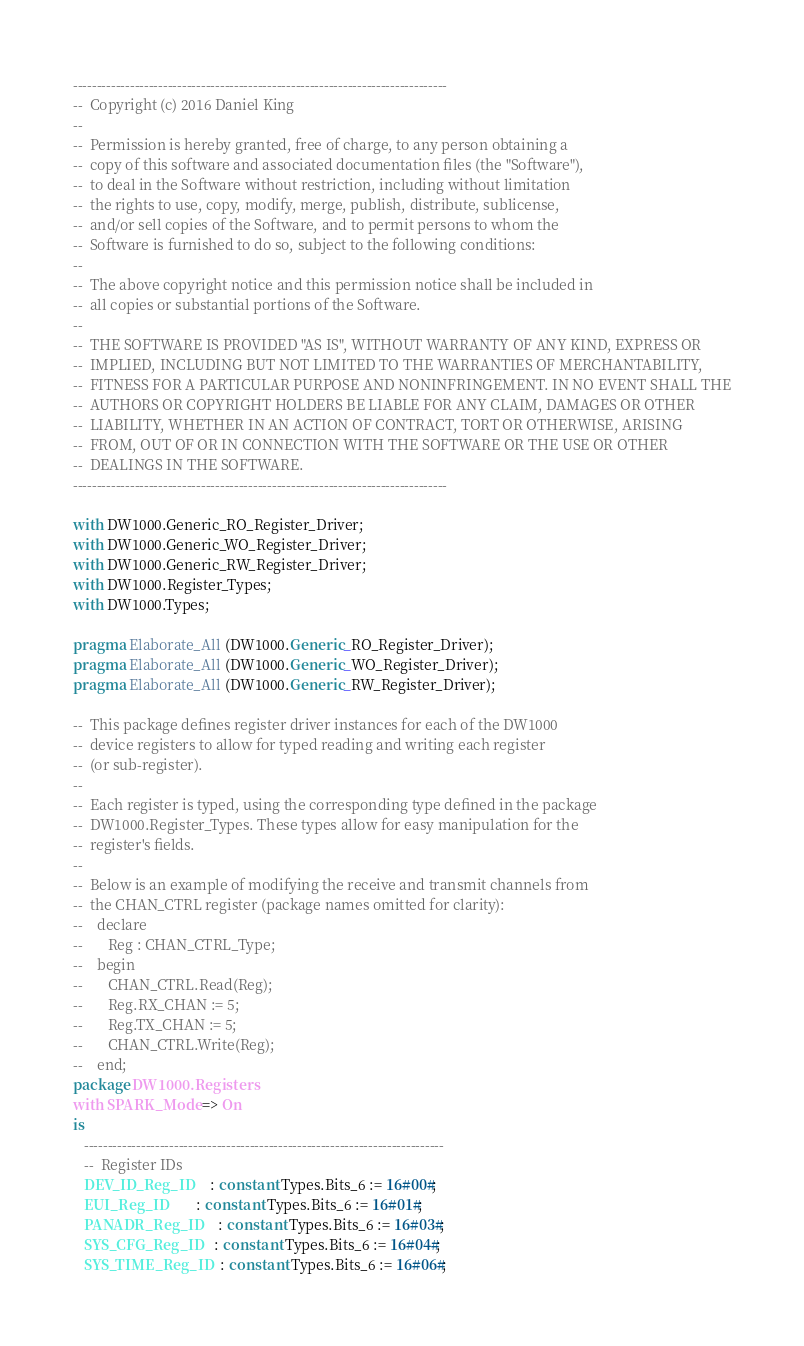Convert code to text. <code><loc_0><loc_0><loc_500><loc_500><_Ada_>-------------------------------------------------------------------------------
--  Copyright (c) 2016 Daniel King
--
--  Permission is hereby granted, free of charge, to any person obtaining a
--  copy of this software and associated documentation files (the "Software"),
--  to deal in the Software without restriction, including without limitation
--  the rights to use, copy, modify, merge, publish, distribute, sublicense,
--  and/or sell copies of the Software, and to permit persons to whom the
--  Software is furnished to do so, subject to the following conditions:
--
--  The above copyright notice and this permission notice shall be included in
--  all copies or substantial portions of the Software.
--
--  THE SOFTWARE IS PROVIDED "AS IS", WITHOUT WARRANTY OF ANY KIND, EXPRESS OR
--  IMPLIED, INCLUDING BUT NOT LIMITED TO THE WARRANTIES OF MERCHANTABILITY,
--  FITNESS FOR A PARTICULAR PURPOSE AND NONINFRINGEMENT. IN NO EVENT SHALL THE
--  AUTHORS OR COPYRIGHT HOLDERS BE LIABLE FOR ANY CLAIM, DAMAGES OR OTHER
--  LIABILITY, WHETHER IN AN ACTION OF CONTRACT, TORT OR OTHERWISE, ARISING
--  FROM, OUT OF OR IN CONNECTION WITH THE SOFTWARE OR THE USE OR OTHER
--  DEALINGS IN THE SOFTWARE.
-------------------------------------------------------------------------------

with DW1000.Generic_RO_Register_Driver;
with DW1000.Generic_WO_Register_Driver;
with DW1000.Generic_RW_Register_Driver;
with DW1000.Register_Types;
with DW1000.Types;

pragma Elaborate_All (DW1000.Generic_RO_Register_Driver);
pragma Elaborate_All (DW1000.Generic_WO_Register_Driver);
pragma Elaborate_All (DW1000.Generic_RW_Register_Driver);

--  This package defines register driver instances for each of the DW1000
--  device registers to allow for typed reading and writing each register
--  (or sub-register).
--
--  Each register is typed, using the corresponding type defined in the package
--  DW1000.Register_Types. These types allow for easy manipulation for the
--  register's fields.
--
--  Below is an example of modifying the receive and transmit channels from
--  the CHAN_CTRL register (package names omitted for clarity):
--    declare
--       Reg : CHAN_CTRL_Type;
--    begin
--       CHAN_CTRL.Read(Reg);
--       Reg.RX_CHAN := 5;
--       Reg.TX_CHAN := 5;
--       CHAN_CTRL.Write(Reg);
--    end;
package DW1000.Registers
with SPARK_Mode => On
is
   ----------------------------------------------------------------------------
   --  Register IDs
   DEV_ID_Reg_ID     : constant Types.Bits_6 := 16#00#;
   EUI_Reg_ID        : constant Types.Bits_6 := 16#01#;
   PANADR_Reg_ID     : constant Types.Bits_6 := 16#03#;
   SYS_CFG_Reg_ID    : constant Types.Bits_6 := 16#04#;
   SYS_TIME_Reg_ID   : constant Types.Bits_6 := 16#06#;</code> 